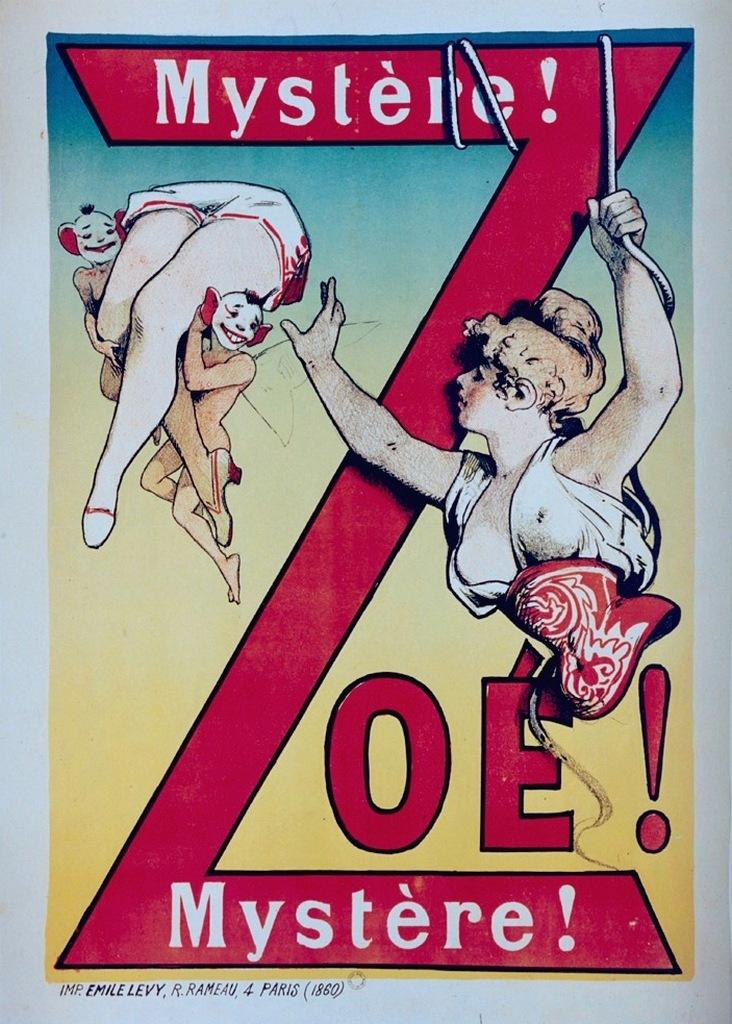What is present in the image? There is a poster in the image. What can be seen on the poster? There are persons depicted on the poster. What type of order is being made by the persons on the poster? There is no indication of an order being made in the image, as it only shows a poster with persons depicted on it. 